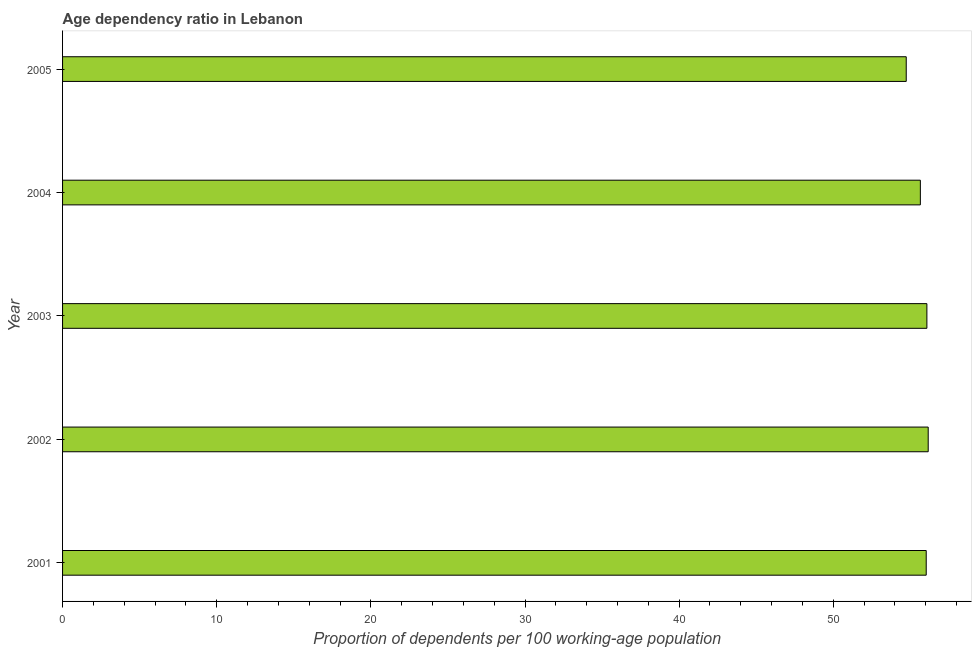Does the graph contain any zero values?
Your response must be concise. No. What is the title of the graph?
Your response must be concise. Age dependency ratio in Lebanon. What is the label or title of the X-axis?
Your answer should be compact. Proportion of dependents per 100 working-age population. What is the age dependency ratio in 2002?
Ensure brevity in your answer.  56.16. Across all years, what is the maximum age dependency ratio?
Your response must be concise. 56.16. Across all years, what is the minimum age dependency ratio?
Ensure brevity in your answer.  54.73. In which year was the age dependency ratio maximum?
Your answer should be very brief. 2002. In which year was the age dependency ratio minimum?
Keep it short and to the point. 2005. What is the sum of the age dependency ratio?
Provide a succinct answer. 278.64. What is the difference between the age dependency ratio in 2002 and 2003?
Provide a short and direct response. 0.09. What is the average age dependency ratio per year?
Give a very brief answer. 55.73. What is the median age dependency ratio?
Provide a short and direct response. 56.03. What is the ratio of the age dependency ratio in 2002 to that in 2005?
Provide a succinct answer. 1.03. What is the difference between the highest and the second highest age dependency ratio?
Ensure brevity in your answer.  0.09. What is the difference between the highest and the lowest age dependency ratio?
Keep it short and to the point. 1.43. What is the difference between two consecutive major ticks on the X-axis?
Provide a succinct answer. 10. What is the Proportion of dependents per 100 working-age population of 2001?
Give a very brief answer. 56.03. What is the Proportion of dependents per 100 working-age population of 2002?
Give a very brief answer. 56.16. What is the Proportion of dependents per 100 working-age population of 2003?
Provide a short and direct response. 56.07. What is the Proportion of dependents per 100 working-age population of 2004?
Make the answer very short. 55.65. What is the Proportion of dependents per 100 working-age population in 2005?
Provide a short and direct response. 54.73. What is the difference between the Proportion of dependents per 100 working-age population in 2001 and 2002?
Provide a succinct answer. -0.13. What is the difference between the Proportion of dependents per 100 working-age population in 2001 and 2003?
Ensure brevity in your answer.  -0.04. What is the difference between the Proportion of dependents per 100 working-age population in 2001 and 2004?
Offer a very short reply. 0.38. What is the difference between the Proportion of dependents per 100 working-age population in 2001 and 2005?
Ensure brevity in your answer.  1.3. What is the difference between the Proportion of dependents per 100 working-age population in 2002 and 2003?
Provide a succinct answer. 0.09. What is the difference between the Proportion of dependents per 100 working-age population in 2002 and 2004?
Give a very brief answer. 0.51. What is the difference between the Proportion of dependents per 100 working-age population in 2002 and 2005?
Provide a succinct answer. 1.43. What is the difference between the Proportion of dependents per 100 working-age population in 2003 and 2004?
Provide a succinct answer. 0.42. What is the difference between the Proportion of dependents per 100 working-age population in 2003 and 2005?
Ensure brevity in your answer.  1.34. What is the difference between the Proportion of dependents per 100 working-age population in 2004 and 2005?
Offer a very short reply. 0.92. What is the ratio of the Proportion of dependents per 100 working-age population in 2001 to that in 2002?
Keep it short and to the point. 1. What is the ratio of the Proportion of dependents per 100 working-age population in 2001 to that in 2005?
Make the answer very short. 1.02. What is the ratio of the Proportion of dependents per 100 working-age population in 2002 to that in 2004?
Offer a terse response. 1.01. What is the ratio of the Proportion of dependents per 100 working-age population in 2003 to that in 2004?
Keep it short and to the point. 1.01. What is the ratio of the Proportion of dependents per 100 working-age population in 2003 to that in 2005?
Your answer should be very brief. 1.02. 